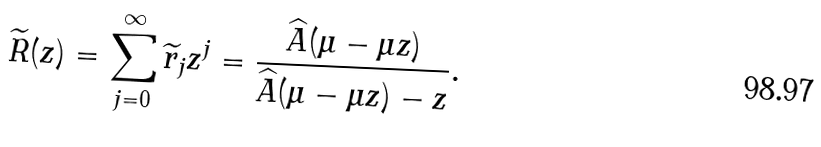<formula> <loc_0><loc_0><loc_500><loc_500>\widetilde { R } ( z ) = \sum _ { j = 0 } ^ { \infty } \widetilde { r } _ { j } z ^ { j } = \frac { \widehat { A } ( \mu - \mu z ) } { \widehat { A } ( \mu - \mu z ) - z } .</formula> 